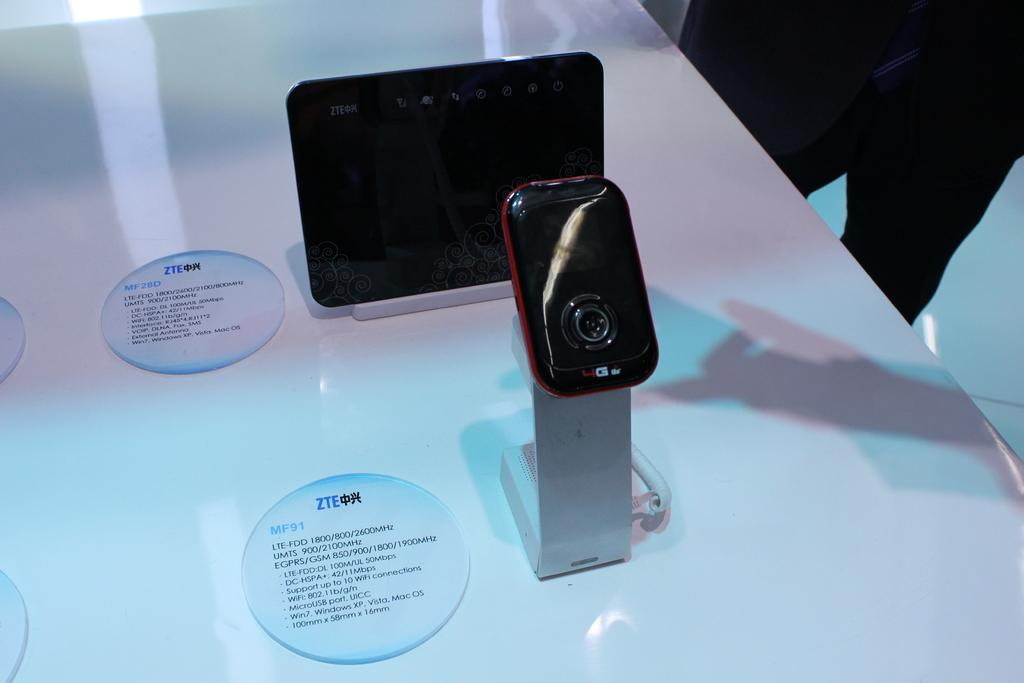<image>
Write a terse but informative summary of the picture. Two devices with labels beside them, writing is foreign language but the brand appears to be ZTE. 